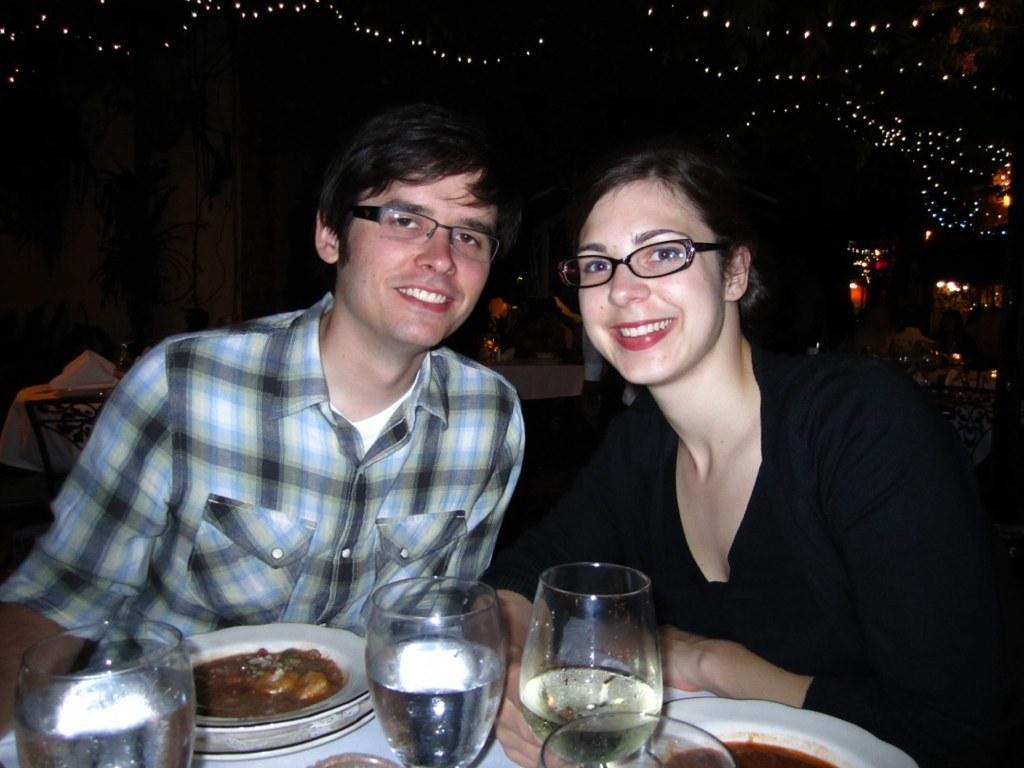In one or two sentences, can you explain what this image depicts? In this picture we can see there are two persons sitting. In front of the two persons, there is a table and on the table, there are glasses and plates. Behind the people, there are decorative lights, some objects, a plant and the dark background. 